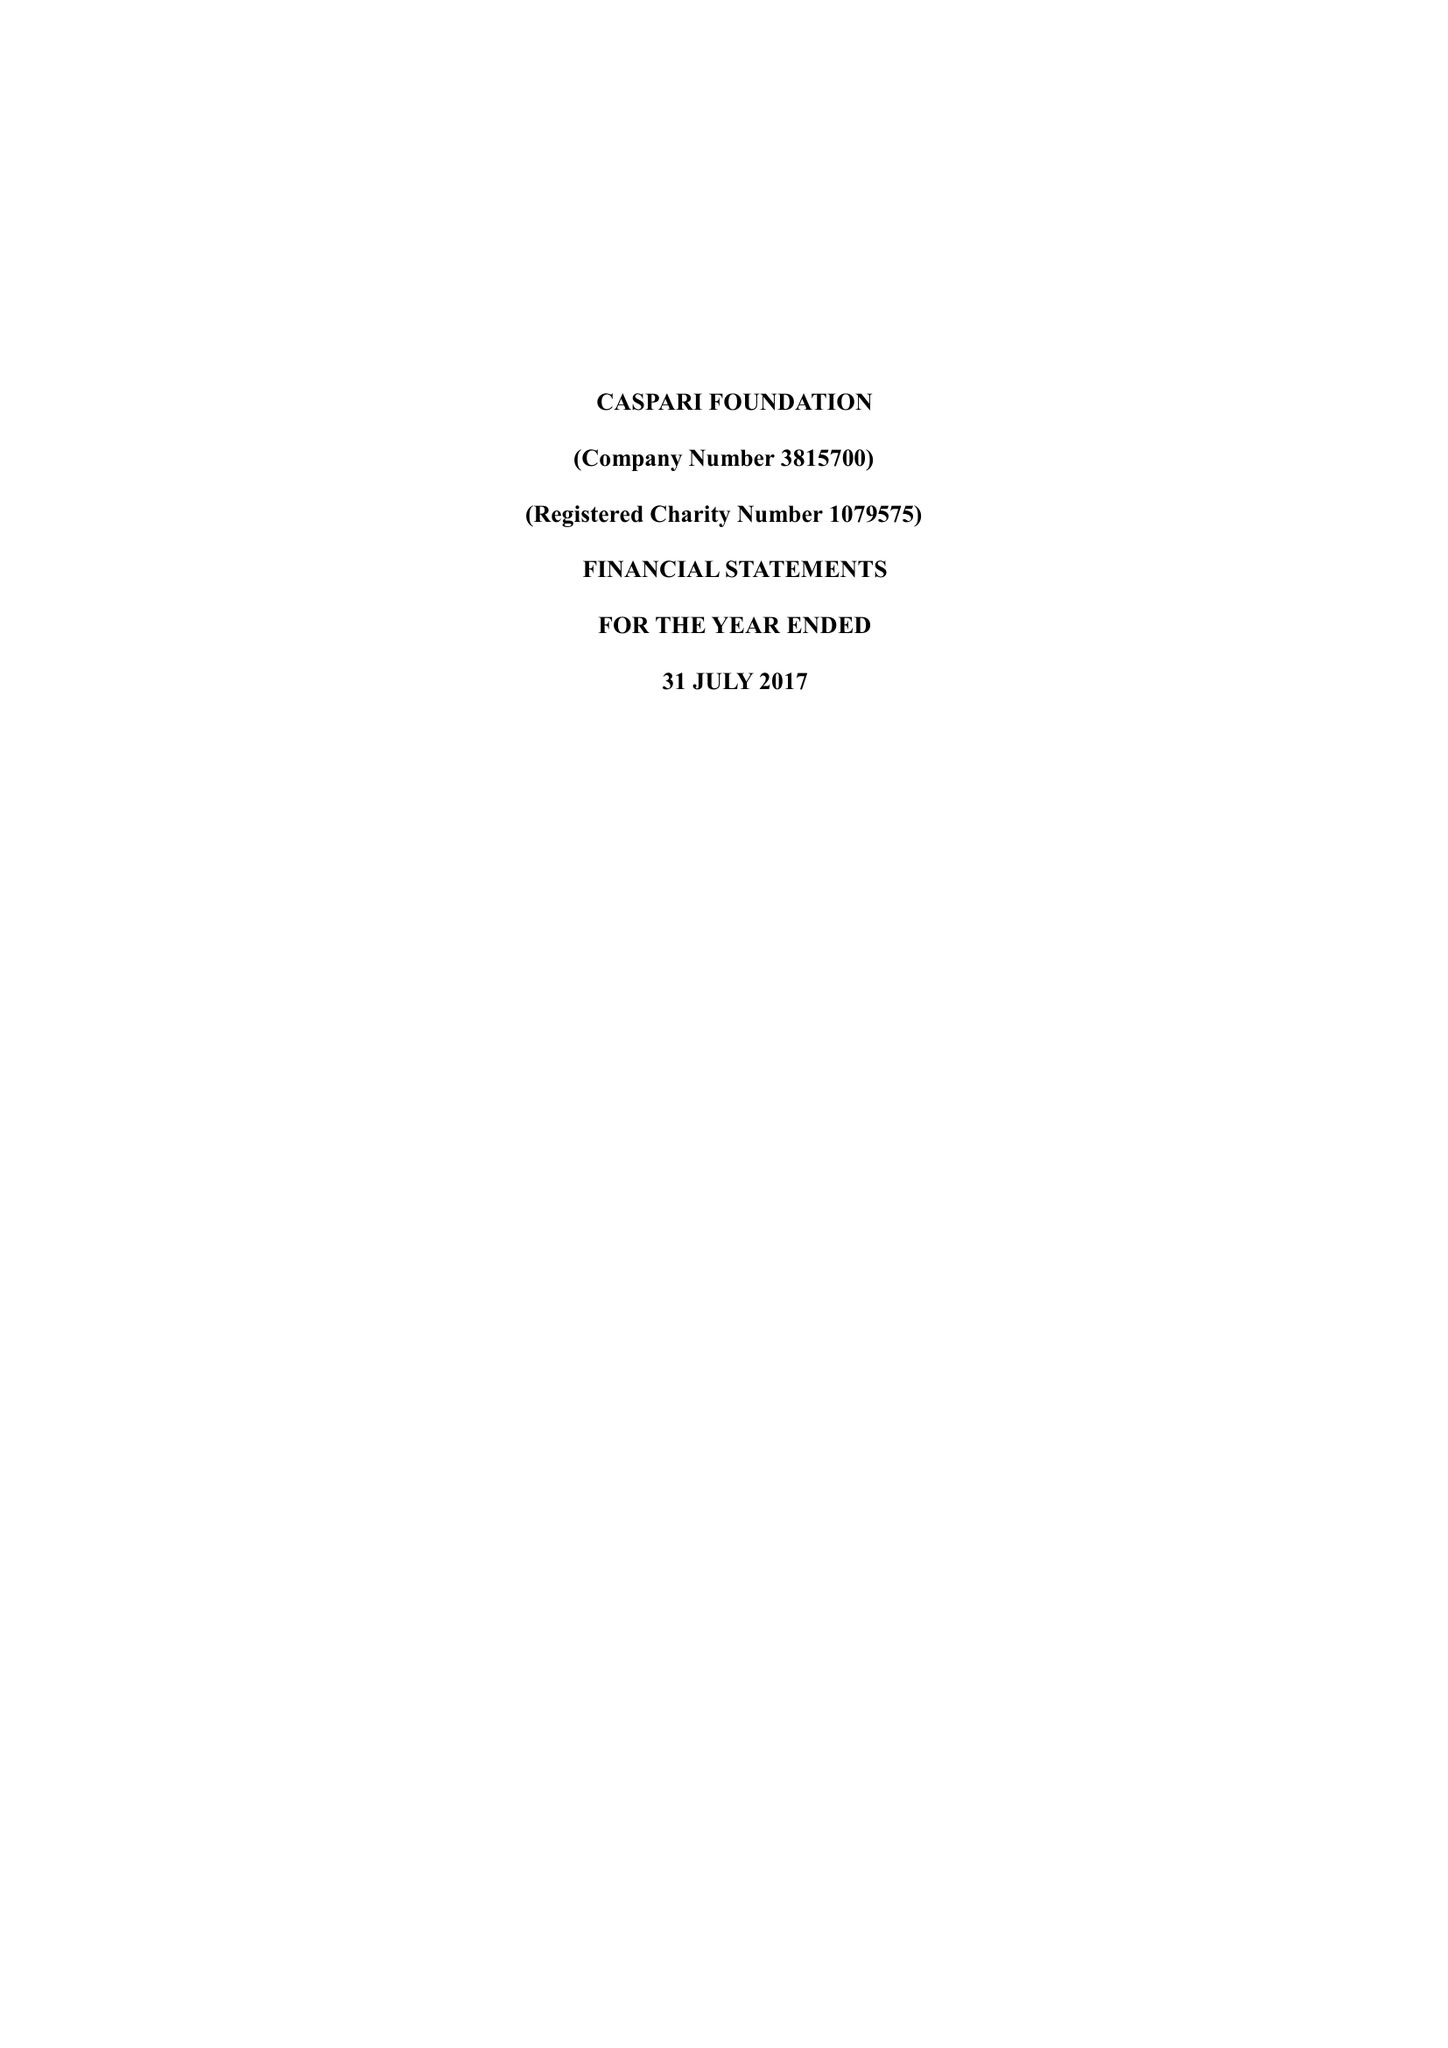What is the value for the address__street_line?
Answer the question using a single word or phrase. 225-229 SEVEN SISTERS ROAD 